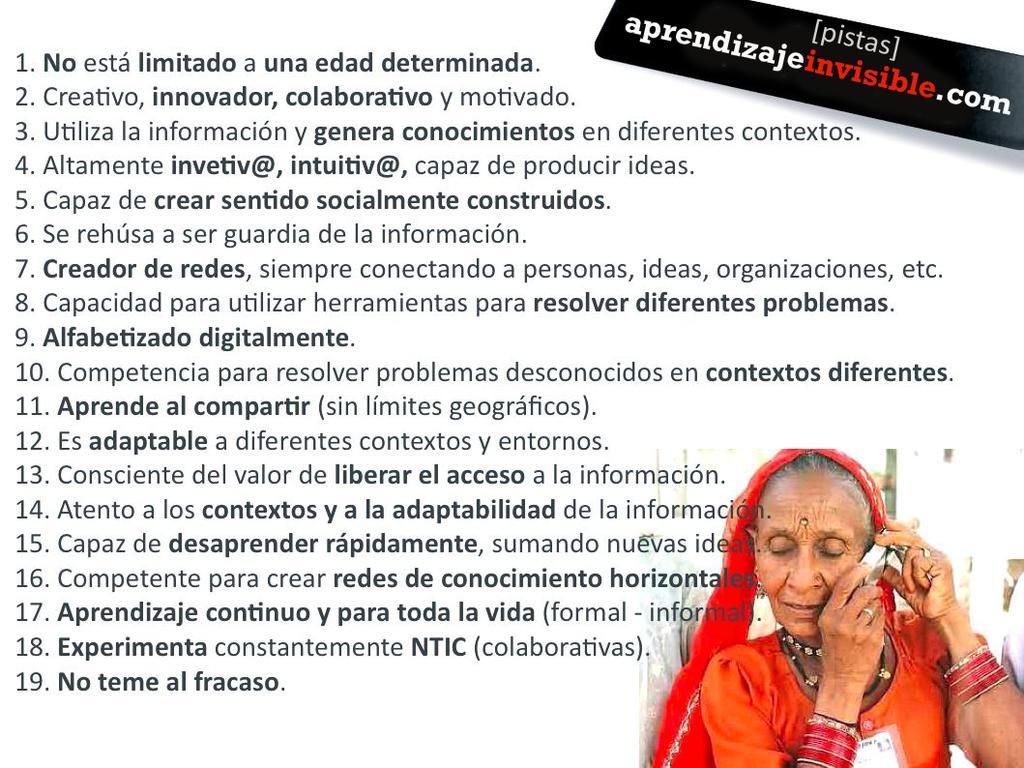Describe this image in one or two sentences. In the picture I can see a woman is holding an object in hands. The woman is wearing bangles and some other objects. I can also see something written on the image. 